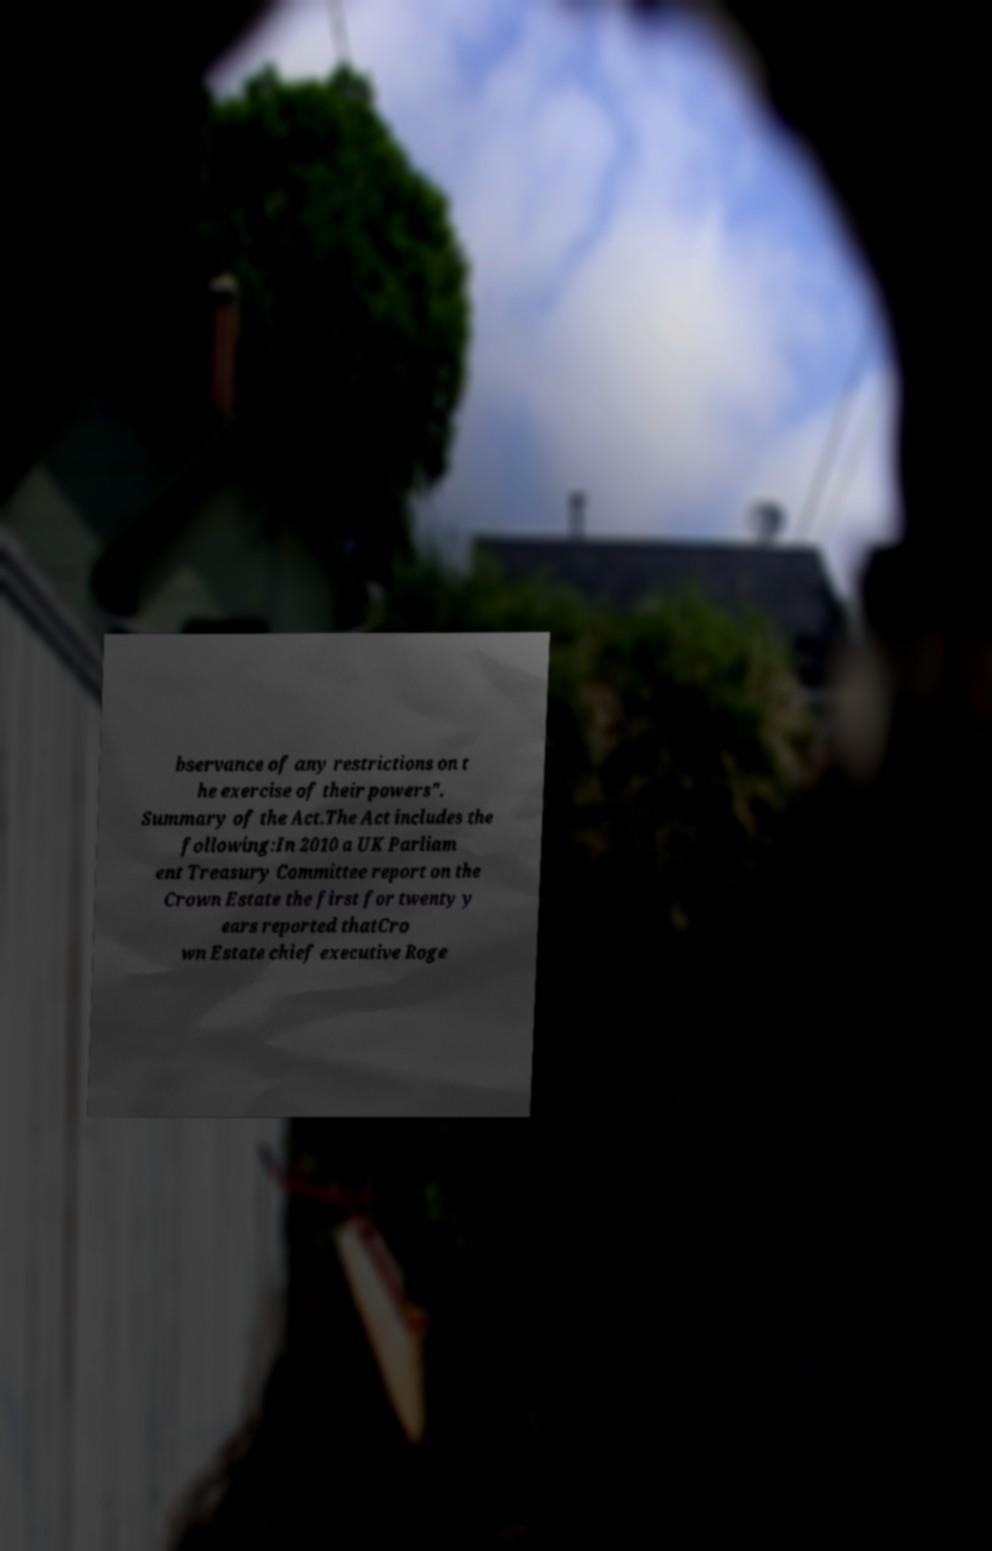Can you accurately transcribe the text from the provided image for me? bservance of any restrictions on t he exercise of their powers". Summary of the Act.The Act includes the following:In 2010 a UK Parliam ent Treasury Committee report on the Crown Estate the first for twenty y ears reported thatCro wn Estate chief executive Roge 